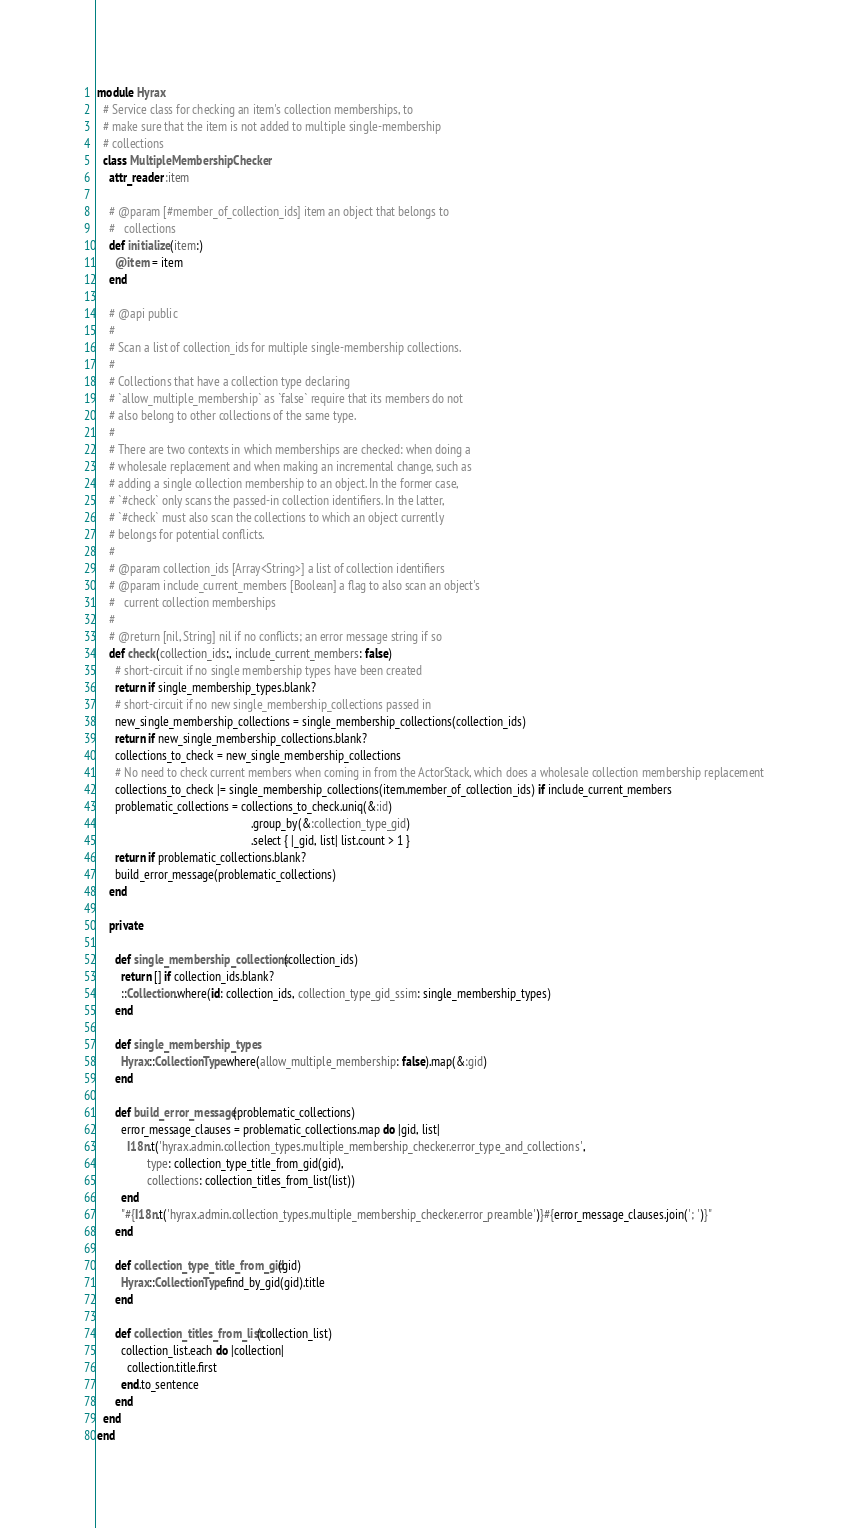<code> <loc_0><loc_0><loc_500><loc_500><_Ruby_>module Hyrax
  # Service class for checking an item's collection memberships, to
  # make sure that the item is not added to multiple single-membership
  # collections
  class MultipleMembershipChecker
    attr_reader :item

    # @param [#member_of_collection_ids] item an object that belongs to
    #   collections
    def initialize(item:)
      @item = item
    end

    # @api public
    #
    # Scan a list of collection_ids for multiple single-membership collections.
    #
    # Collections that have a collection type declaring
    # `allow_multiple_membership` as `false` require that its members do not
    # also belong to other collections of the same type.
    #
    # There are two contexts in which memberships are checked: when doing a
    # wholesale replacement and when making an incremental change, such as
    # adding a single collection membership to an object. In the former case,
    # `#check` only scans the passed-in collection identifiers. In the latter,
    # `#check` must also scan the collections to which an object currently
    # belongs for potential conflicts.
    #
    # @param collection_ids [Array<String>] a list of collection identifiers
    # @param include_current_members [Boolean] a flag to also scan an object's
    #   current collection memberships
    #
    # @return [nil, String] nil if no conflicts; an error message string if so
    def check(collection_ids:, include_current_members: false)
      # short-circuit if no single membership types have been created
      return if single_membership_types.blank?
      # short-circuit if no new single_membership_collections passed in
      new_single_membership_collections = single_membership_collections(collection_ids)
      return if new_single_membership_collections.blank?
      collections_to_check = new_single_membership_collections
      # No need to check current members when coming in from the ActorStack, which does a wholesale collection membership replacement
      collections_to_check |= single_membership_collections(item.member_of_collection_ids) if include_current_members
      problematic_collections = collections_to_check.uniq(&:id)
                                                    .group_by(&:collection_type_gid)
                                                    .select { |_gid, list| list.count > 1 }
      return if problematic_collections.blank?
      build_error_message(problematic_collections)
    end

    private

      def single_membership_collections(collection_ids)
        return [] if collection_ids.blank?
        ::Collection.where(id: collection_ids, collection_type_gid_ssim: single_membership_types)
      end

      def single_membership_types
        Hyrax::CollectionType.where(allow_multiple_membership: false).map(&:gid)
      end

      def build_error_message(problematic_collections)
        error_message_clauses = problematic_collections.map do |gid, list|
          I18n.t('hyrax.admin.collection_types.multiple_membership_checker.error_type_and_collections',
                 type: collection_type_title_from_gid(gid),
                 collections: collection_titles_from_list(list))
        end
        "#{I18n.t('hyrax.admin.collection_types.multiple_membership_checker.error_preamble')}#{error_message_clauses.join('; ')}"
      end

      def collection_type_title_from_gid(gid)
        Hyrax::CollectionType.find_by_gid(gid).title
      end

      def collection_titles_from_list(collection_list)
        collection_list.each do |collection|
          collection.title.first
        end.to_sentence
      end
  end
end
</code> 